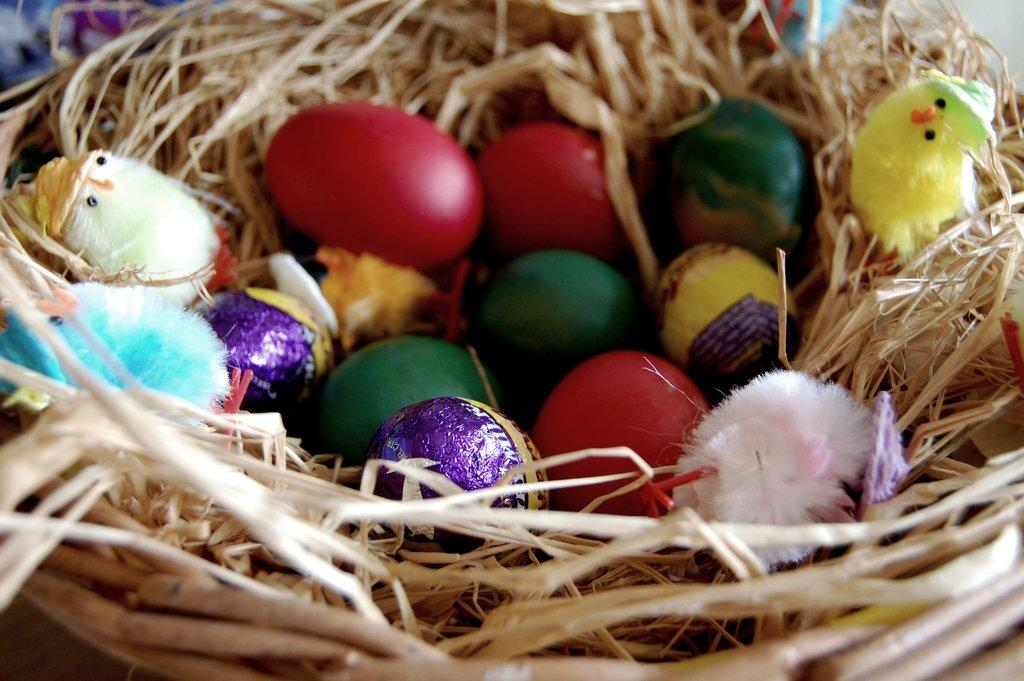What type of objects can be seen in the image? There are colorful eggs and toy birds in the image. Where are the toy birds located? The toy birds are in a nest. What can be observed about the eggs in the image? The eggs are colorful. What type of lunch is the farmer eating in the image? There is no farmer or lunch present in the image; it features colorful eggs and toy birds in a nest. 